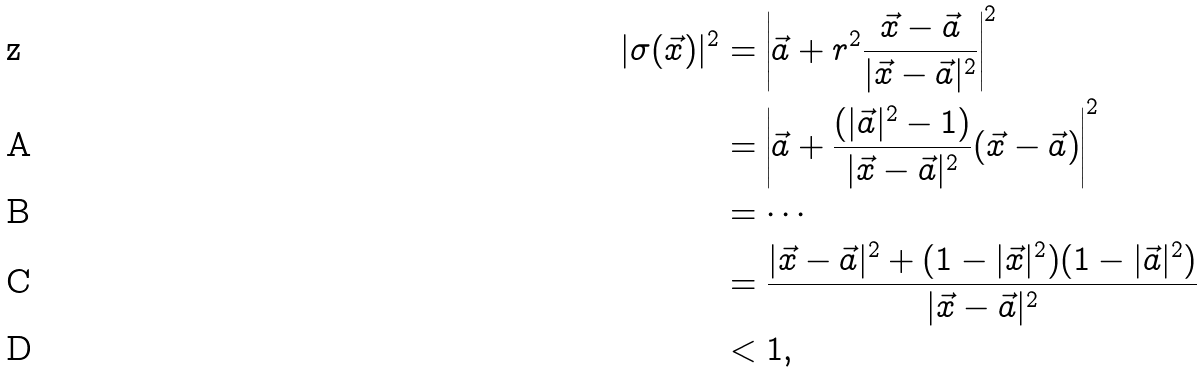Convert formula to latex. <formula><loc_0><loc_0><loc_500><loc_500>| \sigma ( \vec { x } ) | ^ { 2 } & = \left | \vec { a } + r ^ { 2 } \frac { \vec { x } - \vec { a } } { | \vec { x } - \vec { a } | ^ { 2 } } \right | ^ { 2 } \\ & = \left | \vec { a } + \frac { ( | \vec { a } | ^ { 2 } - 1 ) } { | \vec { x } - \vec { a } | ^ { 2 } } ( \vec { x } - \vec { a } ) \right | ^ { 2 } \\ & = \cdots \\ & = \frac { | \vec { x } - \vec { a } | ^ { 2 } + ( 1 - | \vec { x } | ^ { 2 } ) ( 1 - | \vec { a } | ^ { 2 } ) } { | \vec { x } - \vec { a } | ^ { 2 } } \\ & < 1 ,</formula> 